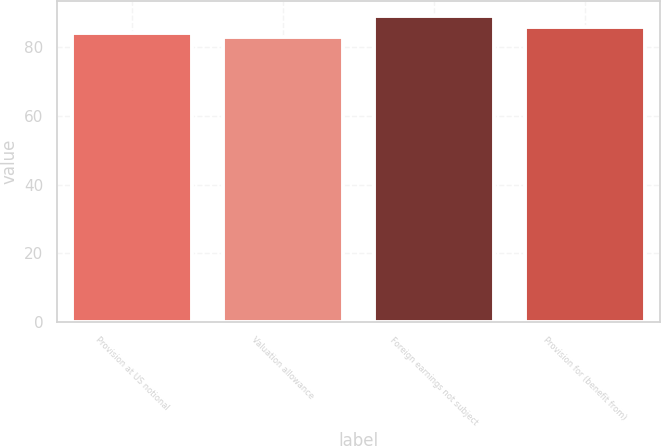Convert chart to OTSL. <chart><loc_0><loc_0><loc_500><loc_500><bar_chart><fcel>Provision at US notional<fcel>Valuation allowance<fcel>Foreign earnings not subject<fcel>Provision for (benefit from)<nl><fcel>84<fcel>83<fcel>89<fcel>86<nl></chart> 